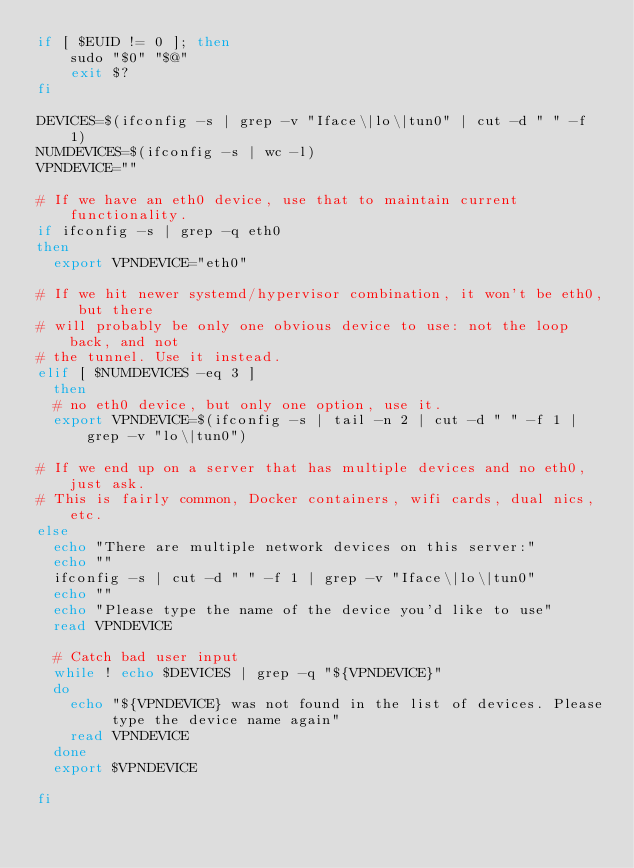Convert code to text. <code><loc_0><loc_0><loc_500><loc_500><_Bash_>if [ $EUID != 0 ]; then
    sudo "$0" "$@"
    exit $?
fi

DEVICES=$(ifconfig -s | grep -v "Iface\|lo\|tun0" | cut -d " " -f 1)
NUMDEVICES=$(ifconfig -s | wc -l)
VPNDEVICE=""

# If we have an eth0 device, use that to maintain current functionality.
if ifconfig -s | grep -q eth0
then
  export VPNDEVICE="eth0"

# If we hit newer systemd/hypervisor combination, it won't be eth0, but there
# will probably be only one obvious device to use: not the loop back, and not
# the tunnel. Use it instead.
elif [ $NUMDEVICES -eq 3 ] 
  then
  # no eth0 device, but only one option, use it.
  export VPNDEVICE=$(ifconfig -s | tail -n 2 | cut -d " " -f 1 | grep -v "lo\|tun0")

# If we end up on a server that has multiple devices and no eth0, just ask.
# This is fairly common, Docker containers, wifi cards, dual nics, etc.
else
  echo "There are multiple network devices on this server:"
  echo ""
  ifconfig -s | cut -d " " -f 1 | grep -v "Iface\|lo\|tun0"
  echo ""
  echo "Please type the name of the device you'd like to use"
  read VPNDEVICE

  # Catch bad user input  
  while ! echo $DEVICES | grep -q "${VPNDEVICE}"
  do
    echo "${VPNDEVICE} was not found in the list of devices. Please type the device name again"
    read VPNDEVICE
  done
  export $VPNDEVICE

fi
</code> 